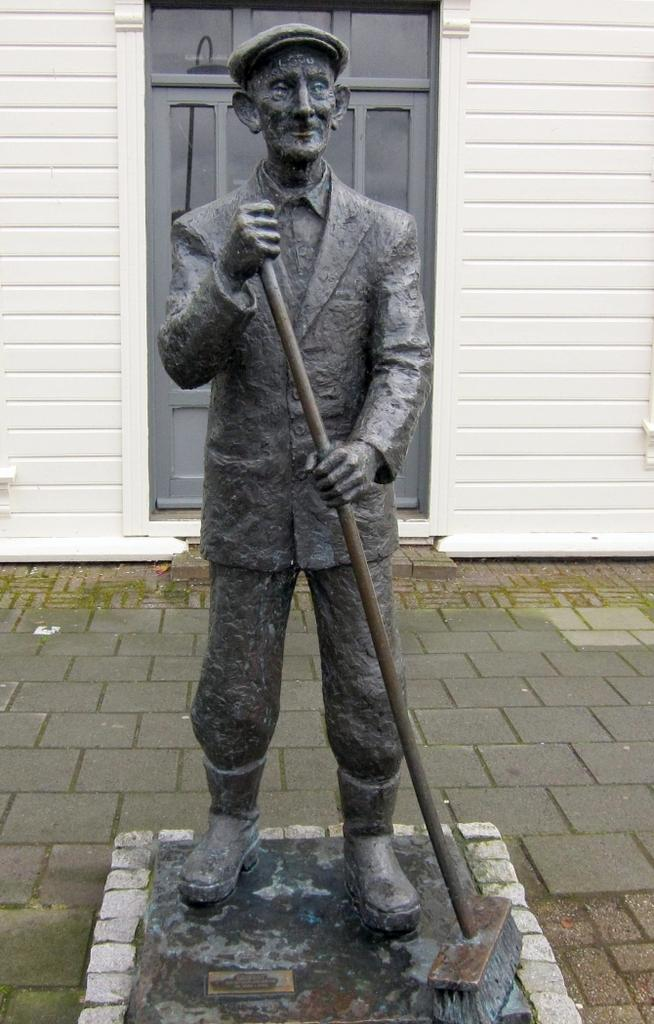What is the main subject of the image? There is a statue of a person in the image. How is the statue positioned in the image? The statue is on a pedestal. What is the person in the statue holding in their hand? The person is holding something in their hand. What type of headwear is the person in the statue wearing? The person is wearing a cap. What can be seen in the background of the image? There is a wall with a door in the background of the image. What is the texture of the cart in the image? There is no cart present in the image. 